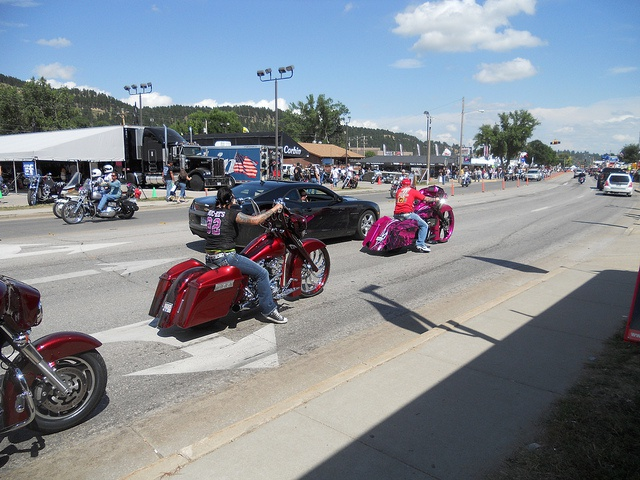Describe the objects in this image and their specific colors. I can see motorcycle in darkgray, black, gray, and maroon tones, motorcycle in darkgray, maroon, black, gray, and brown tones, people in darkgray, gray, black, and lightgray tones, truck in darkgray, black, and gray tones, and car in darkgray, black, navy, gray, and blue tones in this image. 